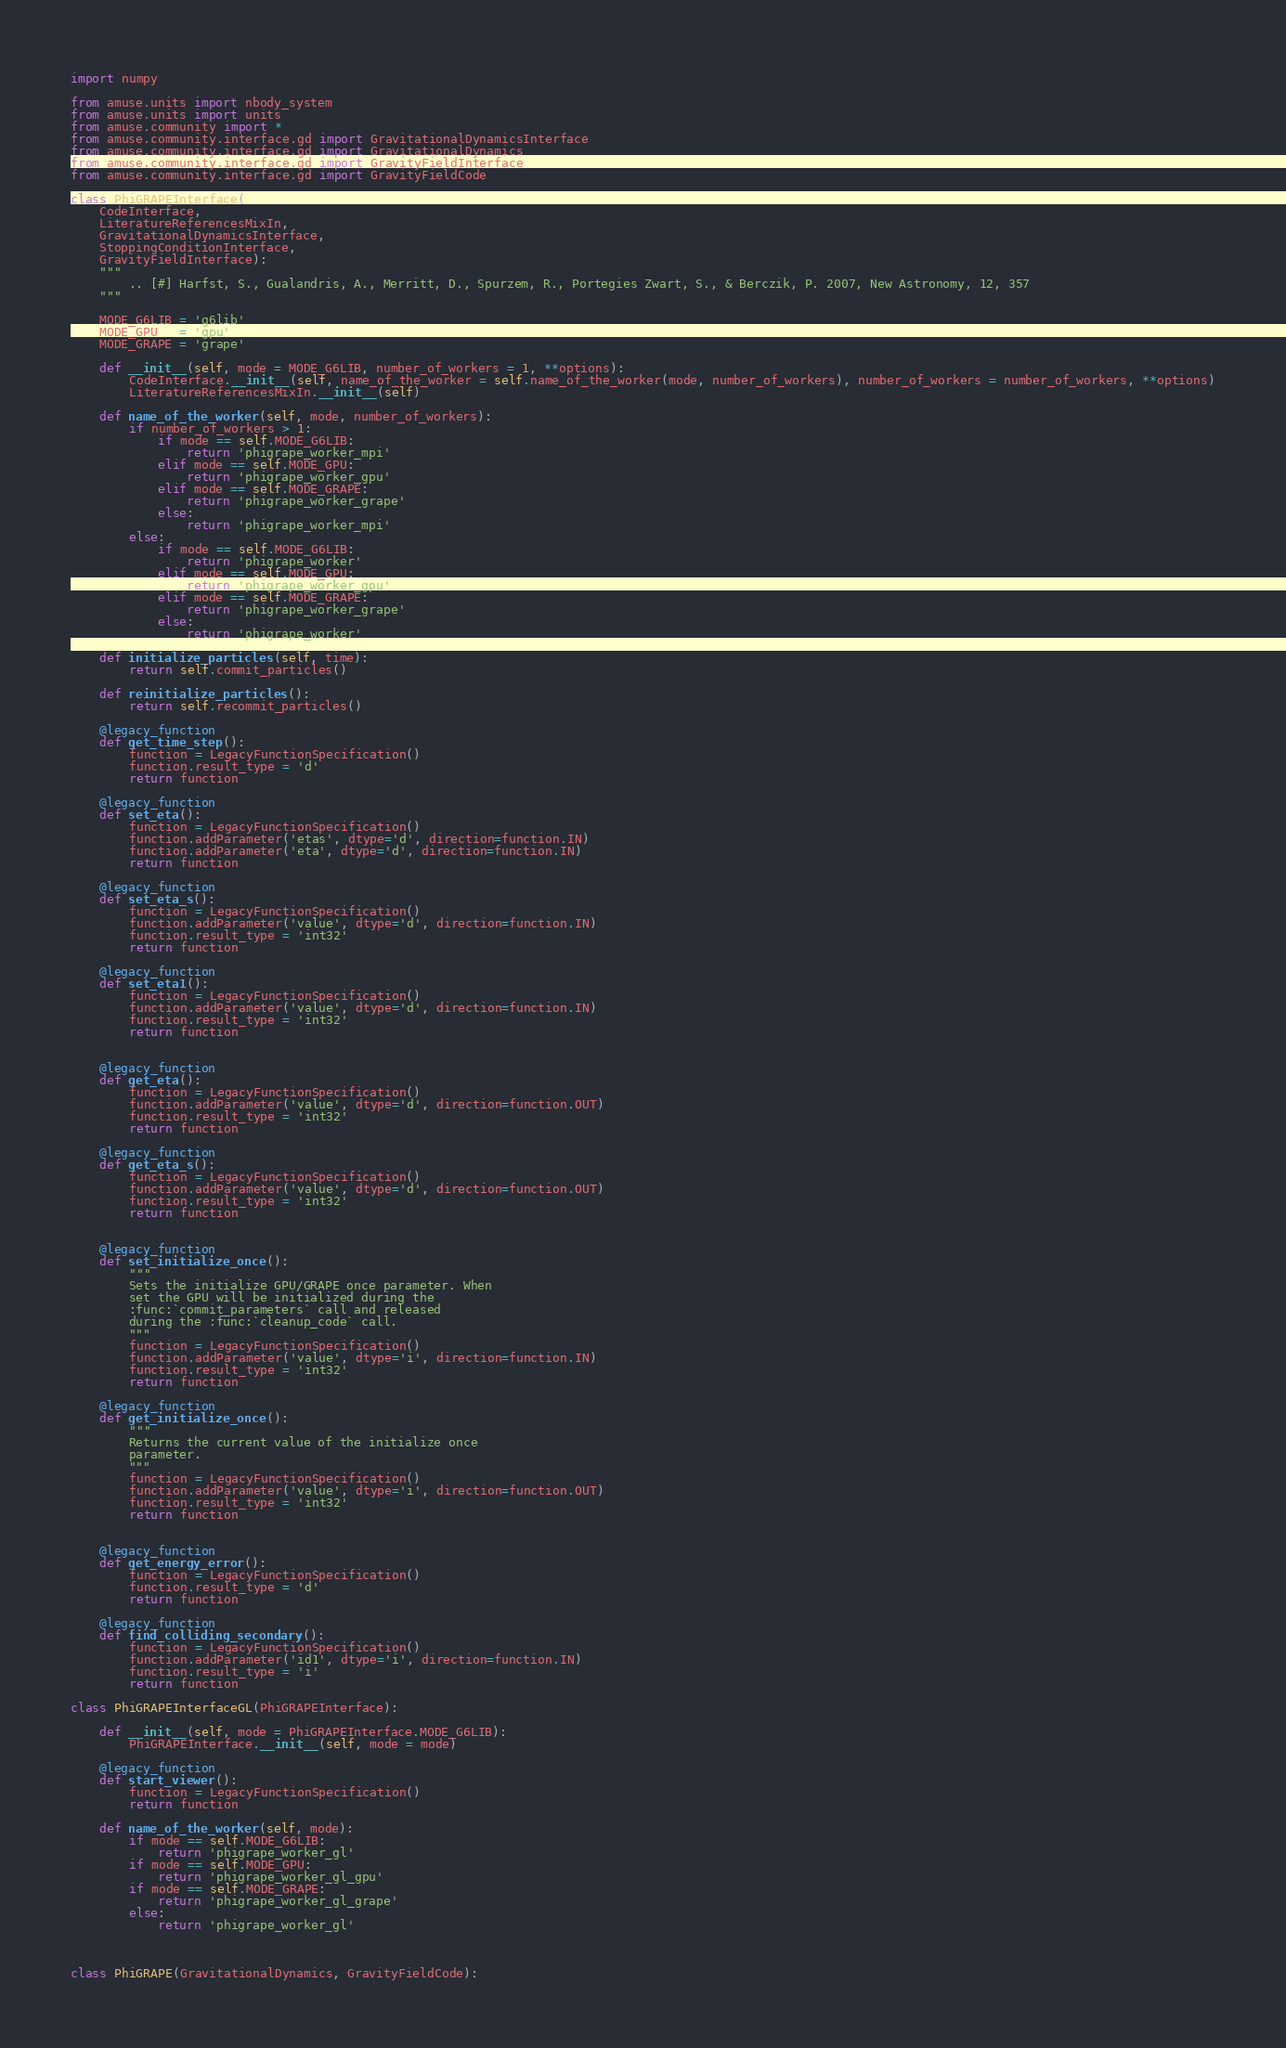Convert code to text. <code><loc_0><loc_0><loc_500><loc_500><_Python_>import numpy

from amuse.units import nbody_system
from amuse.units import units
from amuse.community import *
from amuse.community.interface.gd import GravitationalDynamicsInterface
from amuse.community.interface.gd import GravitationalDynamics
from amuse.community.interface.gd import GravityFieldInterface
from amuse.community.interface.gd import GravityFieldCode

class PhiGRAPEInterface(
    CodeInterface, 
    LiteratureReferencesMixIn, 
    GravitationalDynamicsInterface, 
    StoppingConditionInterface,
    GravityFieldInterface):
    """
        .. [#] Harfst, S., Gualandris, A., Merritt, D., Spurzem, R., Portegies Zwart, S., & Berczik, P. 2007, New Astronomy, 12, 357
    """

    MODE_G6LIB = 'g6lib'
    MODE_GPU   = 'gpu'
    MODE_GRAPE = 'grape'

    def __init__(self, mode = MODE_G6LIB, number_of_workers = 1, **options):
        CodeInterface.__init__(self, name_of_the_worker = self.name_of_the_worker(mode, number_of_workers), number_of_workers = number_of_workers, **options)
        LiteratureReferencesMixIn.__init__(self)

    def name_of_the_worker(self, mode, number_of_workers):
        if number_of_workers > 1:
            if mode == self.MODE_G6LIB:
                return 'phigrape_worker_mpi'
            elif mode == self.MODE_GPU:
                return 'phigrape_worker_gpu'
            elif mode == self.MODE_GRAPE:
                return 'phigrape_worker_grape'
            else:
                return 'phigrape_worker_mpi'
        else:
            if mode == self.MODE_G6LIB:
                return 'phigrape_worker'
            elif mode == self.MODE_GPU:
                return 'phigrape_worker_gpu'
            elif mode == self.MODE_GRAPE:
                return 'phigrape_worker_grape'
            else:
                return 'phigrape_worker'

    def initialize_particles(self, time):
        return self.commit_particles()

    def reinitialize_particles():
        return self.recommit_particles()

    @legacy_function
    def get_time_step():
        function = LegacyFunctionSpecification()
        function.result_type = 'd'
        return function

    @legacy_function
    def set_eta():
        function = LegacyFunctionSpecification()
        function.addParameter('etas', dtype='d', direction=function.IN)
        function.addParameter('eta', dtype='d', direction=function.IN)
        return function

    @legacy_function
    def set_eta_s():
        function = LegacyFunctionSpecification()
        function.addParameter('value', dtype='d', direction=function.IN)
        function.result_type = 'int32'
        return function

    @legacy_function
    def set_eta1():
        function = LegacyFunctionSpecification()
        function.addParameter('value', dtype='d', direction=function.IN)
        function.result_type = 'int32'
        return function


    @legacy_function
    def get_eta():
        function = LegacyFunctionSpecification()
        function.addParameter('value', dtype='d', direction=function.OUT)
        function.result_type = 'int32'
        return function

    @legacy_function
    def get_eta_s():
        function = LegacyFunctionSpecification()
        function.addParameter('value', dtype='d', direction=function.OUT)
        function.result_type = 'int32'
        return function


    @legacy_function
    def set_initialize_once():
        """
        Sets the initialize GPU/GRAPE once parameter. When
        set the GPU will be initialized during the
        :func:`commit_parameters` call and released
        during the :func:`cleanup_code` call.
        """
        function = LegacyFunctionSpecification()
        function.addParameter('value', dtype='i', direction=function.IN)
        function.result_type = 'int32'
        return function
        
    @legacy_function
    def get_initialize_once():
        """
        Returns the current value of the initialize once
        parameter.
        """
        function = LegacyFunctionSpecification()
        function.addParameter('value', dtype='i', direction=function.OUT)
        function.result_type = 'int32'
        return function


    @legacy_function
    def get_energy_error():
        function = LegacyFunctionSpecification()
        function.result_type = 'd'
        return function

    @legacy_function
    def find_colliding_secondary():
        function = LegacyFunctionSpecification()
        function.addParameter('id1', dtype='i', direction=function.IN)
        function.result_type = 'i'
        return function

class PhiGRAPEInterfaceGL(PhiGRAPEInterface):

    def __init__(self, mode = PhiGRAPEInterface.MODE_G6LIB):
        PhiGRAPEInterface.__init__(self, mode = mode)

    @legacy_function
    def start_viewer():
        function = LegacyFunctionSpecification()
        return function

    def name_of_the_worker(self, mode):
        if mode == self.MODE_G6LIB:
            return 'phigrape_worker_gl'
        if mode == self.MODE_GPU:
            return 'phigrape_worker_gl_gpu'
        if mode == self.MODE_GRAPE:
            return 'phigrape_worker_gl_grape'
        else:
            return 'phigrape_worker_gl'



class PhiGRAPE(GravitationalDynamics, GravityFieldCode):
</code> 